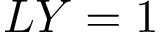Convert formula to latex. <formula><loc_0><loc_0><loc_500><loc_500>L Y = 1</formula> 